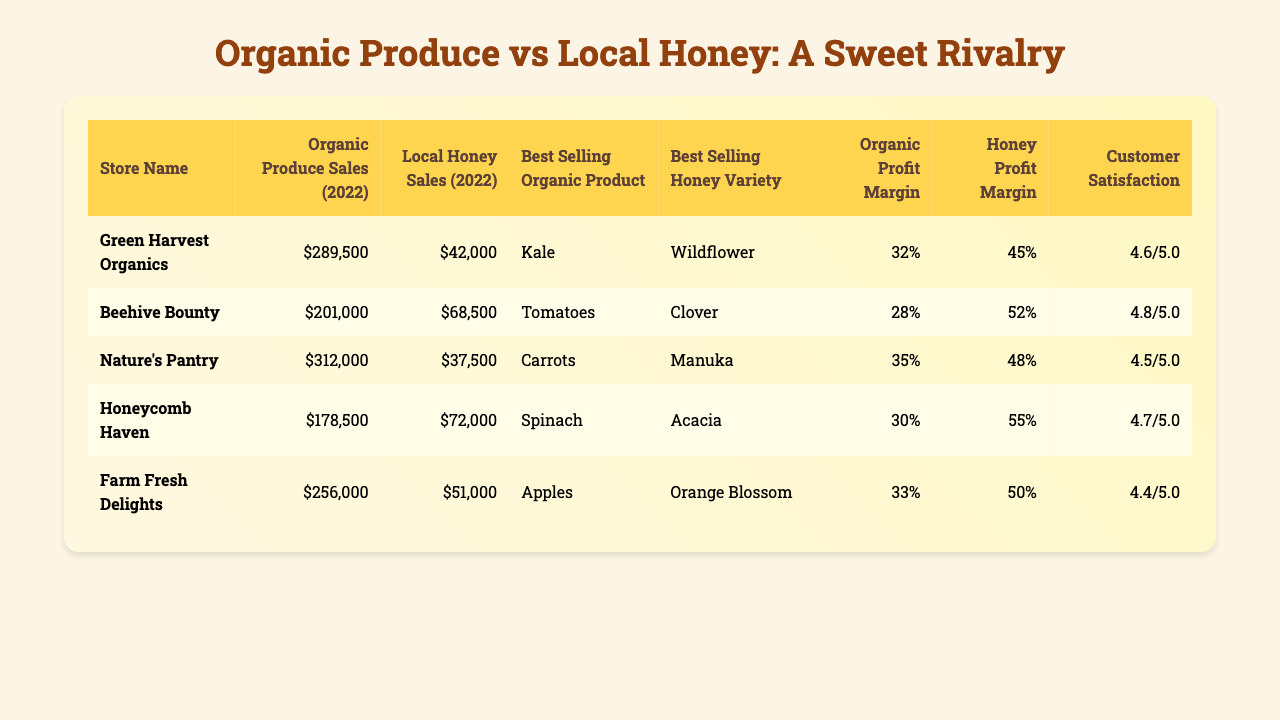What was the highest organic produce sales among the stores? By comparing the organic produce sales values, Green Harvest Organics has the highest sales at $289,500.
Answer: $289,500 Which store had the lowest local honey sales in 2022? The store with the lowest local honey sales is Nature's Pantry with $37,500 in sales.
Answer: Nature's Pantry What is the average organic profit margin across all stores? To find the average organic profit margin, add all profit margins (0.32 + 0.28 + 0.35 + 0.30 + 0.33) = 1.58, then divide by 5 which results in 1.58 / 5 = 0.316, or 31.6%.
Answer: 31.6% Is the customer satisfaction score for Honeycomb Haven higher than for Farm Fresh Delights? Honeycomb Haven has a customer satisfaction score of 4.7, which is higher than Farm Fresh Delights’ score of 4.4, so it is true.
Answer: Yes What is the difference in sales between Green Harvest Organics' organic produce and local honey? Green Harvest Organics has organic produce sales of $289,500 and local honey sales of $42,000. The difference is $289,500 - $42,000 = $247,500.
Answer: $247,500 How does the honey profit margin of Beehive Bounty compare to the customer satisfaction score of Nature's Pantry? Beehive Bounty has a honey profit margin of 52%, while Nature's Pantry has a customer satisfaction score of 4.5 (or 45 out of 100). Since these are different metrics, we can't directly compare them, but they both seem relatively positive.
Answer: Different metrics, not directly comparable Which store had the best-selling organic product of Kale? The store with the best-selling organic product of Kale is Green Harvest Organics.
Answer: Green Harvest Organics What is the total local honey sales across all stores? Adding all local honey sales gives: $42,000 + $68,500 + $37,500 + $72,000 + $51,000 = $271,000.
Answer: $271,000 Which store has the highest customer satisfaction score? By looking at the customer satisfaction scores, Beehive Bounty has the highest score with 4.8.
Answer: Beehive Bounty If you compare the organic profit margin of Honeycomb Haven and Nature's Pantry, which store has a better margin? Honeycomb Haven has an organic profit margin of 30%, while Nature's Pantry has 35%. Since 35% is higher, Nature's Pantry has the better margin.
Answer: Nature's Pantry 